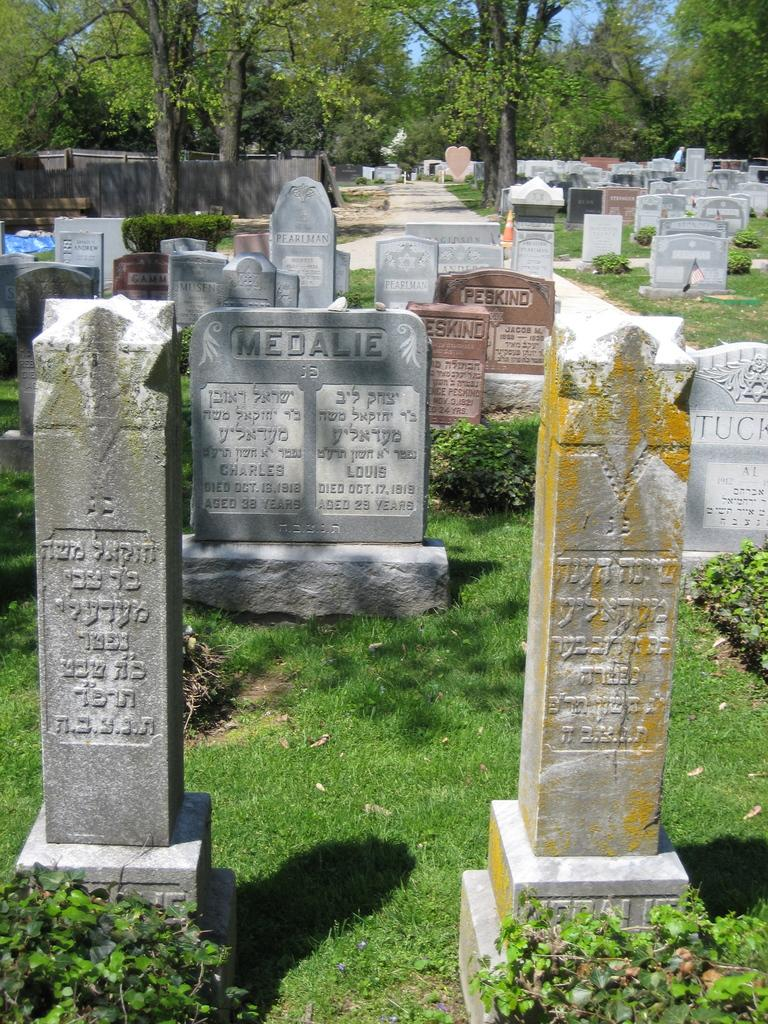What type of location is depicted in the image? The image contains cemeteries. What type of vegetation is present at the bottom of the image? There is grass and plants at the bottom of the image. What can be seen in the background of the image? There is a wall and trees in the background of the image. How much liquid is present in the image? There is no liquid visible in the image. What type of crayon can be seen in the image? There are no crayons present in the image. 